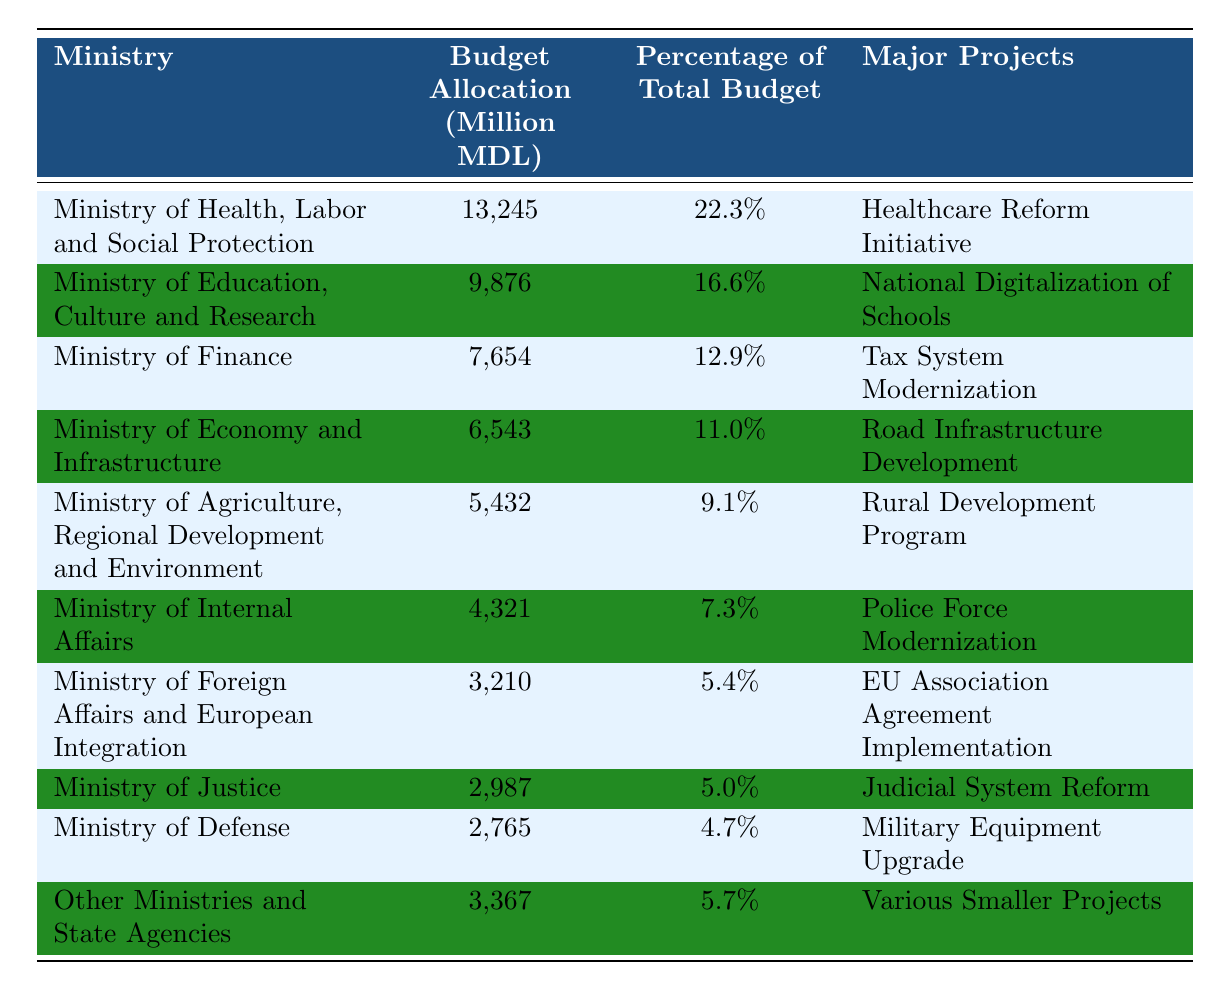What is the budget allocation for the Ministry of Health, Labor and Social Protection? The table shows a budget allocation of 13,245 million MDL for this ministry.
Answer: 13245 million MDL Which ministry has the highest budget allocation? By examining the table, it is clear that the Ministry of Health, Labor and Social Protection has the highest allocation at 13,245 million MDL.
Answer: Ministry of Health, Labor and Social Protection What percentage of the total budget is allocated to the Ministry of Defense? Referring to the table, the percentage for the Ministry of Defense is listed as 4.7%.
Answer: 4.7% What is the total budget allocation for the Ministry of Finance and the Ministry of Internal Affairs combined? The budget allocations are 7,654 million MDL for the Ministry of Finance and 4,321 million MDL for the Ministry of Internal Affairs. Adding these two: 7,654 + 4,321 = 11,975 million MDL.
Answer: 11975 million MDL Is the budget allocation for the Ministry of Education, Culture and Research more than 10,000 million MDL? Checking the table, the allocation for this ministry is 9,876 million MDL, which is less than 10,000 million MDL.
Answer: No What is the average budget allocation of the top three ministries by allocation? The top three ministries are: Ministry of Health (13,245 million MDL), Ministry of Education (9,876 million MDL), and Ministry of Finance (7,654 million MDL). Summing these gives 13,245 + 9,876 + 7,654 = 30,775 million MDL. The average is 30,775 / 3 = 10,258.33 million MDL.
Answer: 10258.33 million MDL Which ministry has a budget allocation closest to the average budget allocation of all ministries? First, sum all the budget allocations: 13,245 + 9,876 + 7,654 + 6,543 + 5,432 + 4,321 + 3,210 + 2,987 + 2,765 + 3,367 = 59,600 million MDL. The average is 59,600 / 10 = 5,960 million MDL. The closest allocation is the Ministry of Agriculture at 5,432 million MDL.
Answer: Ministry of Agriculture, Regional Development and Environment What major project is associated with the Ministry of Foreign Affairs and European Integration? The table indicates that the major project for this ministry is the "EU Association Agreement Implementation".
Answer: EU Association Agreement Implementation How much budget is allocated to 'Other Ministries and State Agencies'? Referring to the table, the budget allocation for 'Other Ministries and State Agencies' is listed as 3,367 million MDL.
Answer: 3367 million MDL What is the difference in budget allocation between the Ministry of Justice and the Ministry of Internal Affairs? The budget for the Ministry of Justice is 2,987 million MDL and for the Ministry of Internal Affairs, it is 4,321 million MDL. The difference is 4,321 - 2,987 = 1,334 million MDL.
Answer: 1334 million MDL 